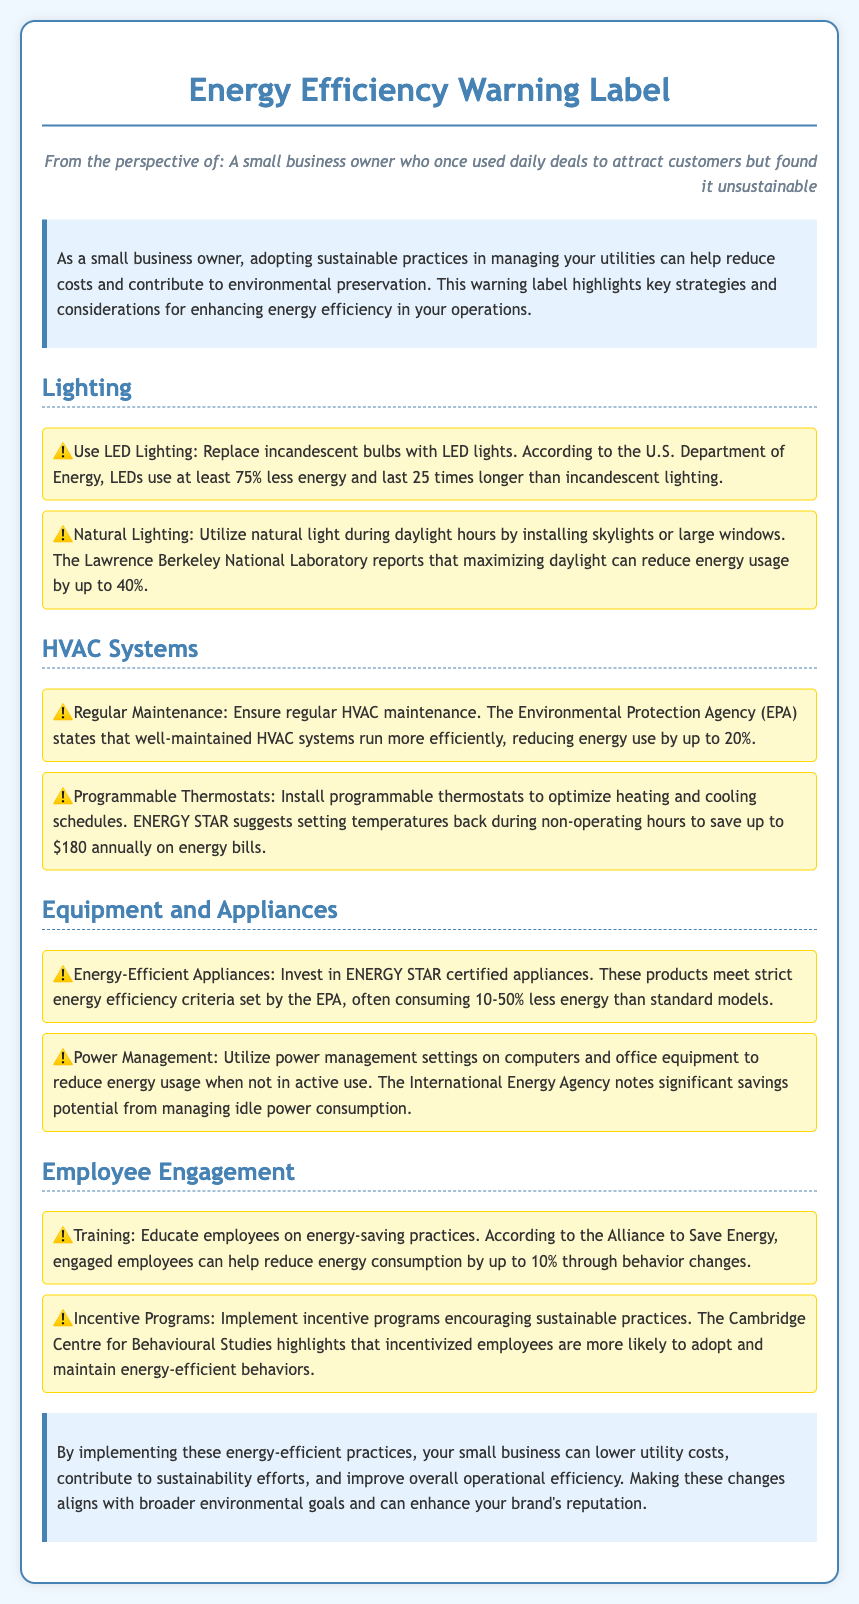What is the main benefit of using LED lighting? The document states that LEDs use at least 75% less energy and last 25 times longer than incandescent lighting.
Answer: 75% less energy How much can programmable thermostats save annually? According to ENERGY STAR, setting temperatures back during non-operating hours can save up to $180 annually on energy bills.
Answer: $180 What percentage of energy use can well-maintained HVAC systems reduce? The EPA indicates that well-maintained HVAC systems can reduce energy use by up to 20%.
Answer: 20% What is one method for utilizing natural light? The document suggests installing skylights or large windows to utilize natural light during daylight hours.
Answer: Skylights or large windows How much energy consumption reduction can engaged employees achieve? According to the Alliance to Save Energy, engaged employees can help reduce energy consumption by up to 10%.
Answer: 10% What type of appliances should small businesses invest in for maximum efficiency? The document states that businesses should invest in ENERGY STAR certified appliances that meet strict energy efficiency criteria.
Answer: ENERGY STAR certified appliances What is a power management practice mentioned in the document? Using power management settings on computers and office equipment to reduce energy usage when not in active use is suggested.
Answer: Power management settings What conclusion does the document provide regarding energy-efficient practices? The conclusion states that implementing these practices can lower utility costs and improve operational efficiency.
Answer: Lower utility costs and improve efficiency What is one incentive for employees to adopt energy-saving practices? The document mentions implementing incentive programs encouraging sustainable practices.
Answer: Incentive programs 